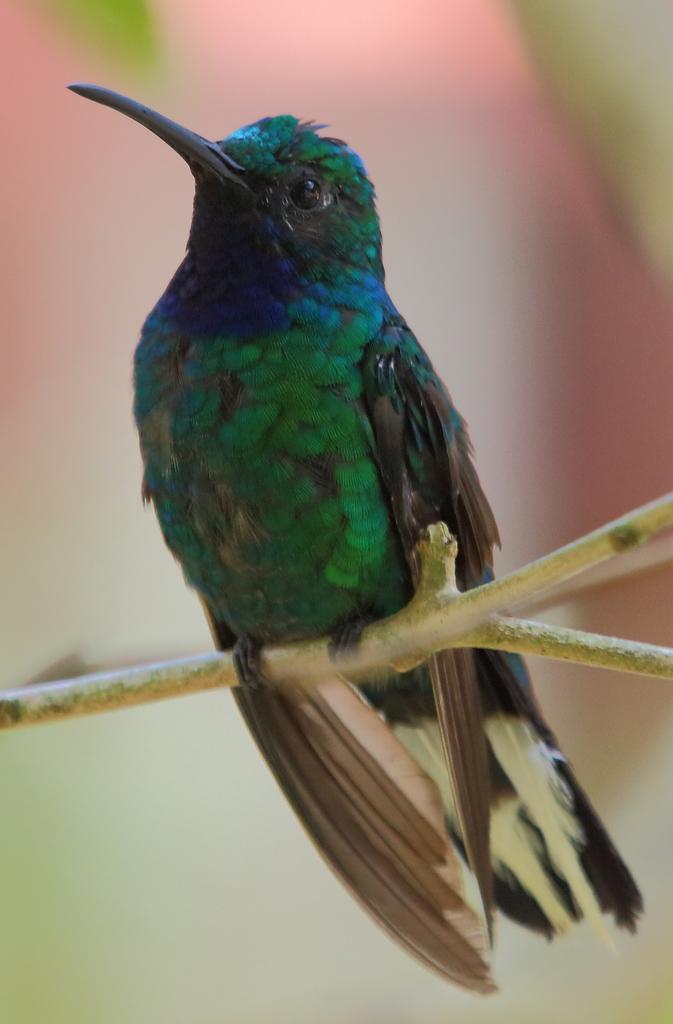Describe this image in one or two sentences. In this picture we can see a bird on a branch and in the background it is blurry. 